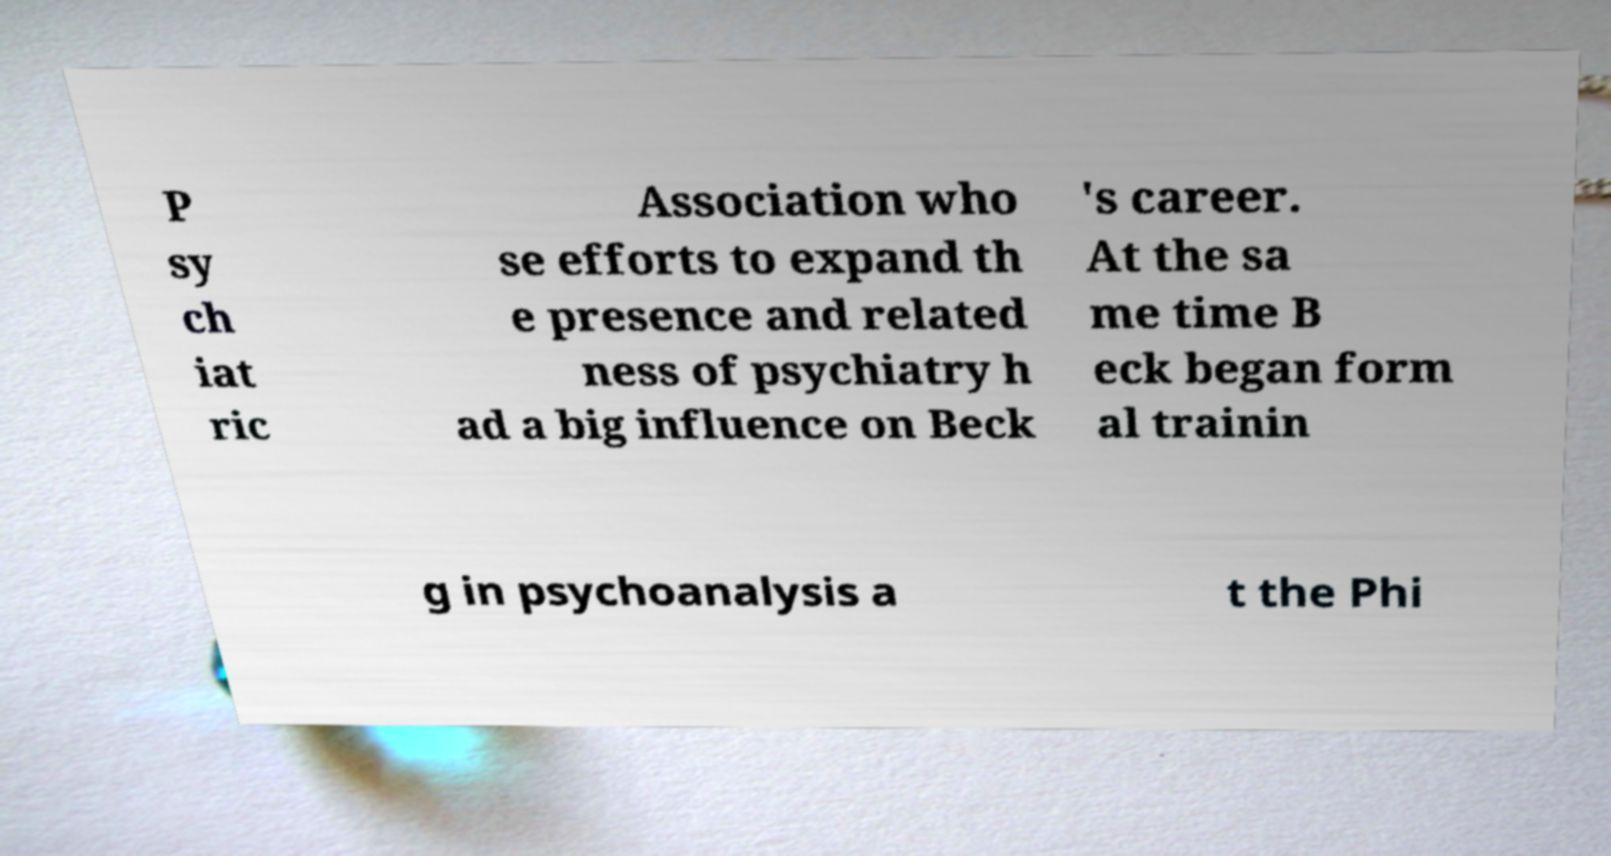What messages or text are displayed in this image? I need them in a readable, typed format. P sy ch iat ric Association who se efforts to expand th e presence and related ness of psychiatry h ad a big influence on Beck 's career. At the sa me time B eck began form al trainin g in psychoanalysis a t the Phi 